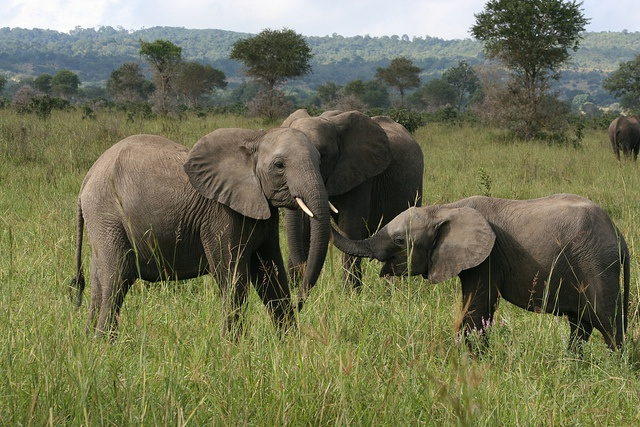Describe the objects in this image and their specific colors. I can see elephant in lavender, black, and gray tones, elephant in lavender, black, gray, and darkgreen tones, elephant in lavender, black, gray, and darkgreen tones, and elephant in lavender, black, and gray tones in this image. 